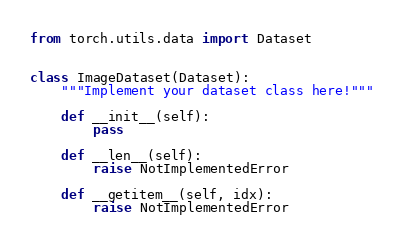Convert code to text. <code><loc_0><loc_0><loc_500><loc_500><_Python_>from torch.utils.data import Dataset


class ImageDataset(Dataset):
    """Implement your dataset class here!"""

    def __init__(self):
        pass

    def __len__(self):
        raise NotImplementedError

    def __getitem__(self, idx):
        raise NotImplementedError
</code> 